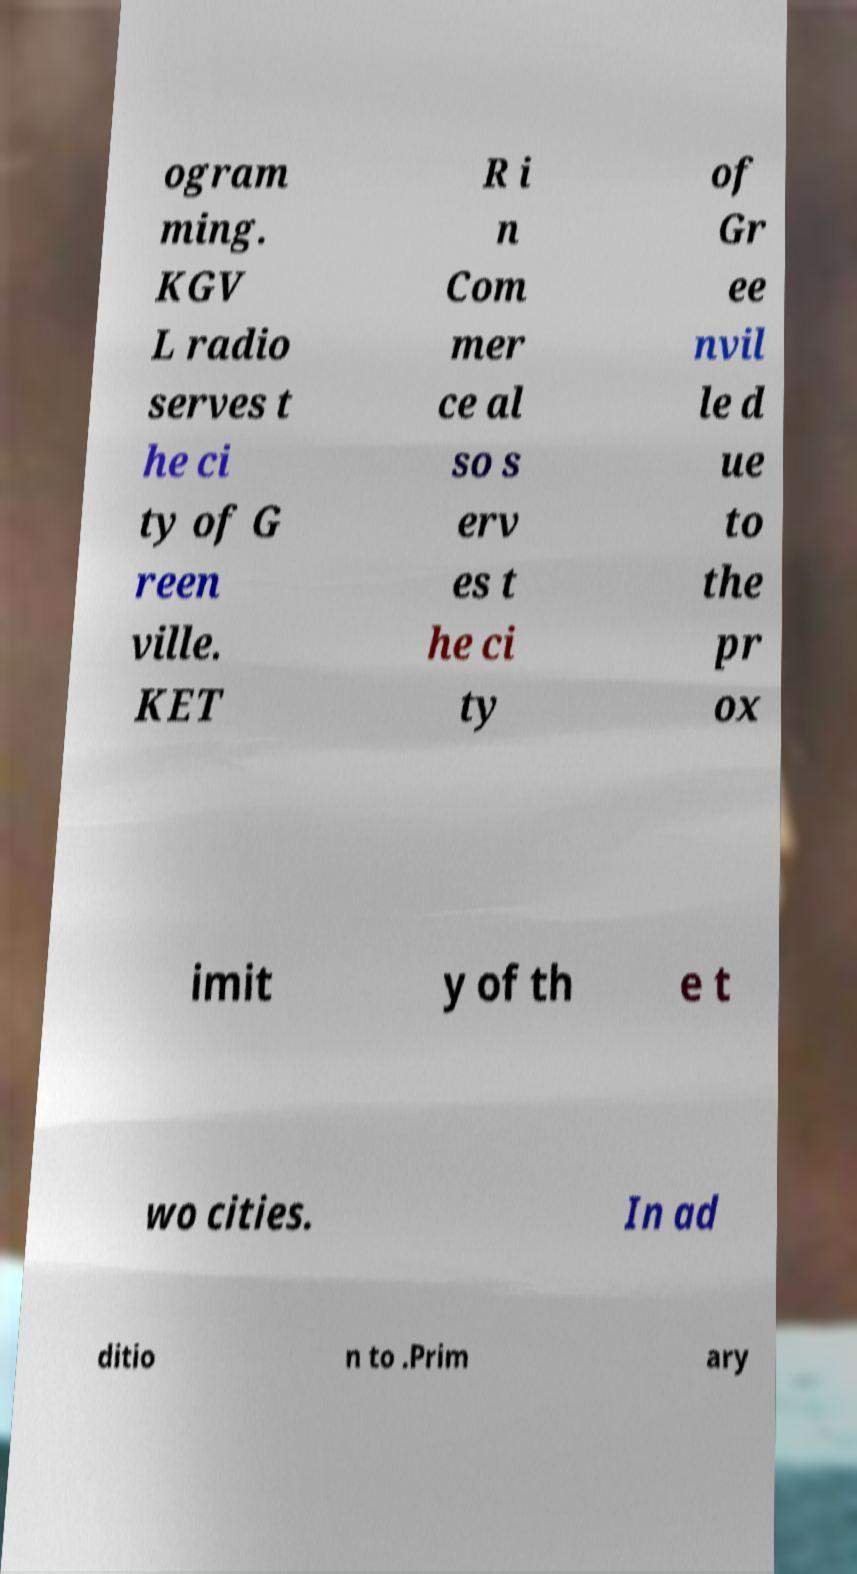What messages or text are displayed in this image? I need them in a readable, typed format. ogram ming. KGV L radio serves t he ci ty of G reen ville. KET R i n Com mer ce al so s erv es t he ci ty of Gr ee nvil le d ue to the pr ox imit y of th e t wo cities. In ad ditio n to .Prim ary 